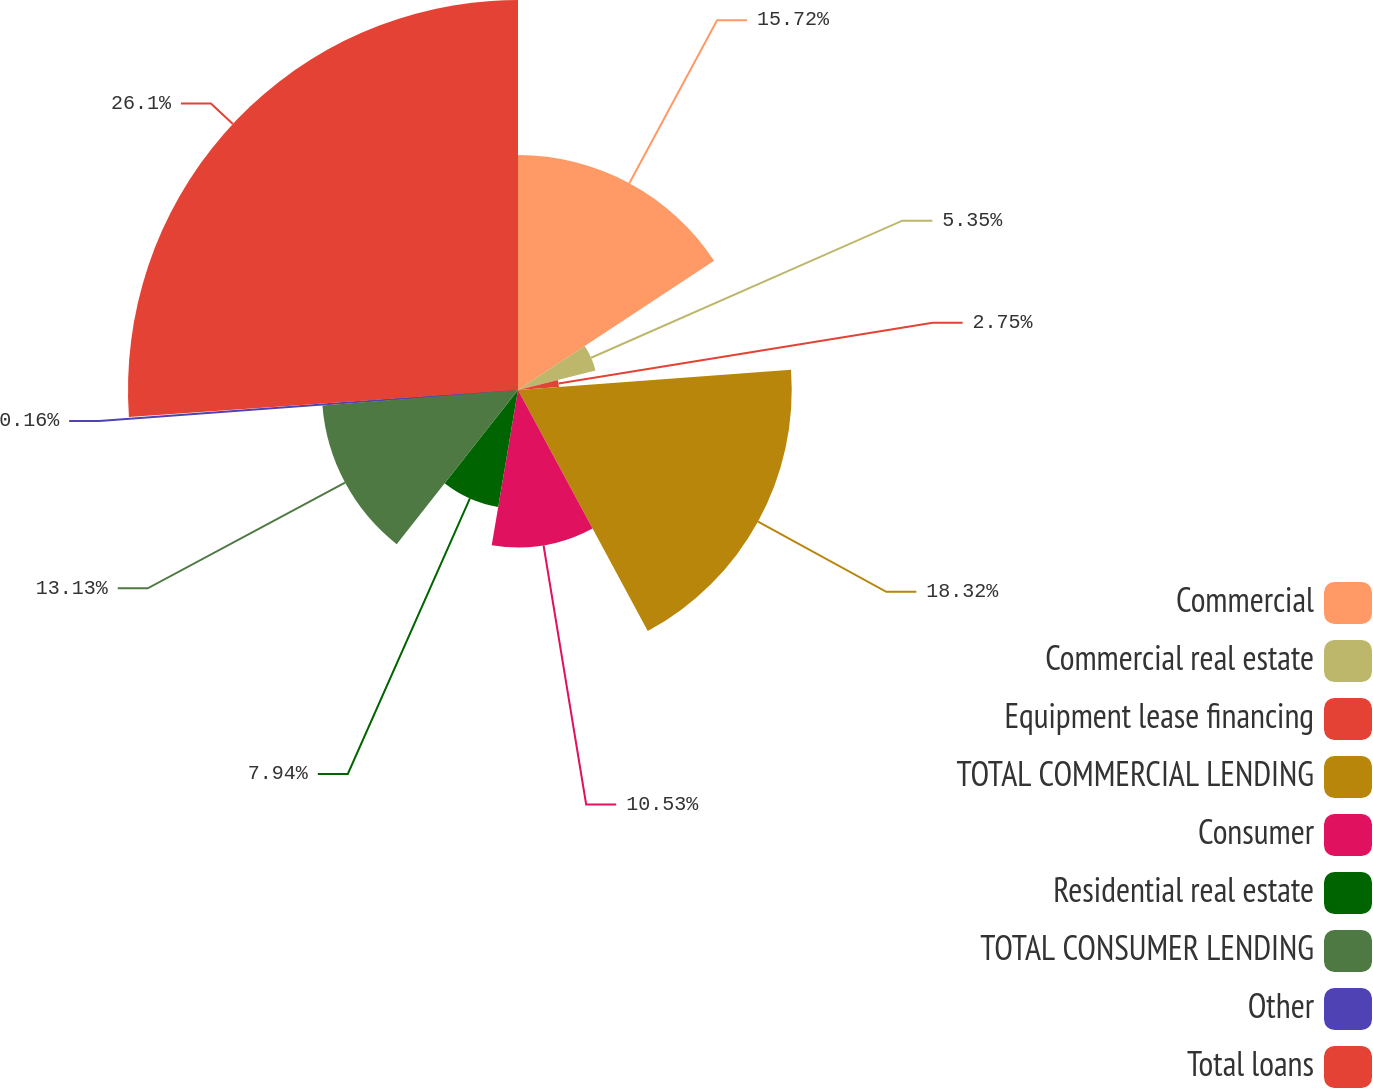Convert chart. <chart><loc_0><loc_0><loc_500><loc_500><pie_chart><fcel>Commercial<fcel>Commercial real estate<fcel>Equipment lease financing<fcel>TOTAL COMMERCIAL LENDING<fcel>Consumer<fcel>Residential real estate<fcel>TOTAL CONSUMER LENDING<fcel>Other<fcel>Total loans<nl><fcel>15.72%<fcel>5.35%<fcel>2.75%<fcel>18.32%<fcel>10.53%<fcel>7.94%<fcel>13.13%<fcel>0.16%<fcel>26.1%<nl></chart> 